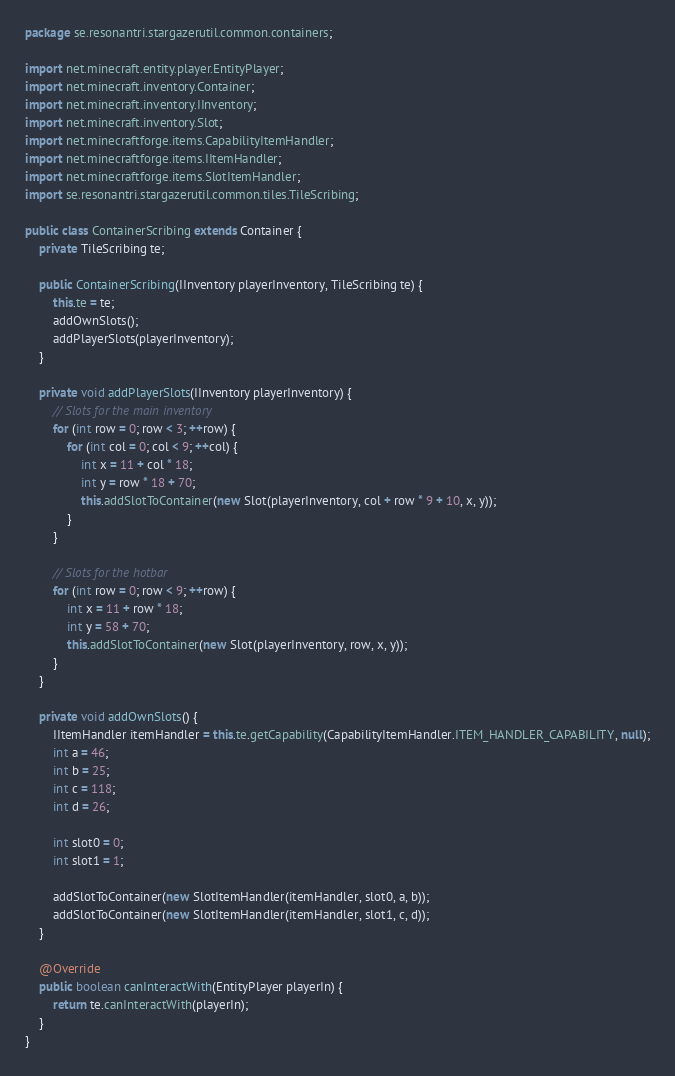Convert code to text. <code><loc_0><loc_0><loc_500><loc_500><_Java_>package se.resonantri.stargazerutil.common.containers;

import net.minecraft.entity.player.EntityPlayer;
import net.minecraft.inventory.Container;
import net.minecraft.inventory.IInventory;
import net.minecraft.inventory.Slot;
import net.minecraftforge.items.CapabilityItemHandler;
import net.minecraftforge.items.IItemHandler;
import net.minecraftforge.items.SlotItemHandler;
import se.resonantri.stargazerutil.common.tiles.TileScribing;

public class ContainerScribing extends Container {
    private TileScribing te;

    public ContainerScribing(IInventory playerInventory, TileScribing te) {
        this.te = te;
        addOwnSlots();
        addPlayerSlots(playerInventory);
    }

    private void addPlayerSlots(IInventory playerInventory) {
        // Slots for the main inventory
        for (int row = 0; row < 3; ++row) {
            for (int col = 0; col < 9; ++col) {
                int x = 11 + col * 18;
                int y = row * 18 + 70;
                this.addSlotToContainer(new Slot(playerInventory, col + row * 9 + 10, x, y));
            }
        }

        // Slots for the hotbar
        for (int row = 0; row < 9; ++row) {
            int x = 11 + row * 18;
            int y = 58 + 70;
            this.addSlotToContainer(new Slot(playerInventory, row, x, y));
        }
    }

    private void addOwnSlots() {
        IItemHandler itemHandler = this.te.getCapability(CapabilityItemHandler.ITEM_HANDLER_CAPABILITY, null);
        int a = 46;
        int b = 25;
        int c = 118;
        int d = 26;

        int slot0 = 0;
        int slot1 = 1;

        addSlotToContainer(new SlotItemHandler(itemHandler, slot0, a, b));
        addSlotToContainer(new SlotItemHandler(itemHandler, slot1, c, d));
    }

    @Override
    public boolean canInteractWith(EntityPlayer playerIn) {
        return te.canInteractWith(playerIn);
    }
}
</code> 